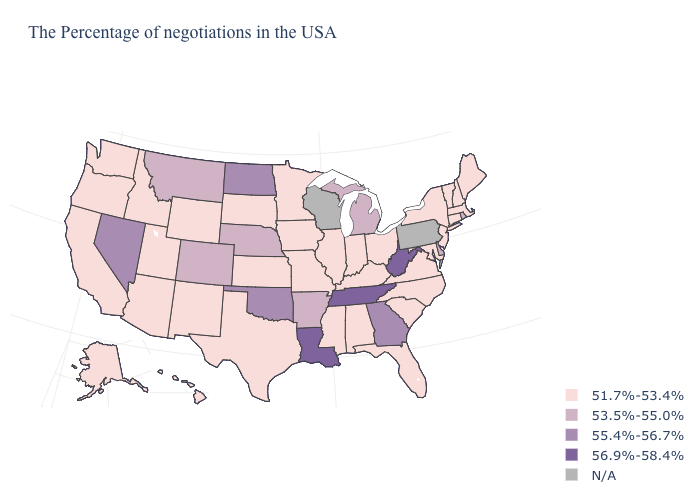Name the states that have a value in the range N/A?
Give a very brief answer. Pennsylvania, Wisconsin. What is the value of Massachusetts?
Give a very brief answer. 51.7%-53.4%. What is the value of New Hampshire?
Be succinct. 51.7%-53.4%. Does Maryland have the lowest value in the South?
Answer briefly. Yes. Does Rhode Island have the lowest value in the Northeast?
Answer briefly. No. What is the lowest value in states that border Delaware?
Give a very brief answer. 51.7%-53.4%. Among the states that border Texas , does New Mexico have the lowest value?
Answer briefly. Yes. Among the states that border North Dakota , which have the highest value?
Quick response, please. Montana. Does the first symbol in the legend represent the smallest category?
Quick response, please. Yes. Among the states that border Maryland , does Delaware have the highest value?
Concise answer only. No. How many symbols are there in the legend?
Short answer required. 5. Does Wyoming have the highest value in the USA?
Be succinct. No. 